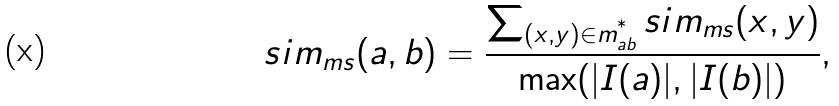<formula> <loc_0><loc_0><loc_500><loc_500>s i m _ { m s } ( a , b ) = \frac { \sum _ { ( x , y ) \in m ^ { ^ { * } } _ { a b } } s i m _ { m s } ( x , y ) } { \max ( | I ( a ) | , | I ( b ) | ) } ,</formula> 